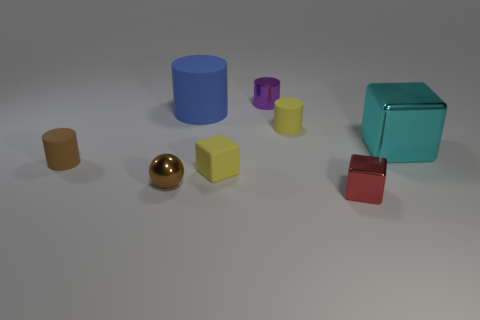How many brown metal cylinders have the same size as the purple cylinder?
Keep it short and to the point. 0. There is a tiny cube that is left of the shiny block that is in front of the tiny brown metallic sphere; how many small brown rubber cylinders are in front of it?
Your response must be concise. 0. Is the number of matte objects to the right of the red shiny object the same as the number of purple objects that are to the right of the brown metal object?
Provide a succinct answer. No. How many other brown objects are the same shape as the brown shiny thing?
Offer a terse response. 0. Is there another sphere that has the same material as the tiny ball?
Give a very brief answer. No. What shape is the tiny matte object that is the same color as the tiny sphere?
Provide a succinct answer. Cylinder. How many large cyan cylinders are there?
Make the answer very short. 0. How many blocks are either red shiny objects or small metallic things?
Give a very brief answer. 1. There is a metallic cylinder that is the same size as the red metal cube; what is its color?
Give a very brief answer. Purple. What number of objects are both in front of the yellow block and behind the tiny metallic block?
Make the answer very short. 1. 